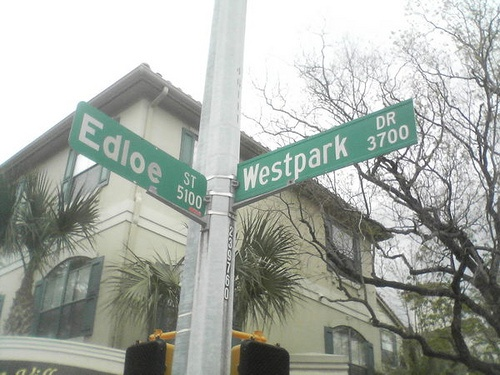Describe the objects in this image and their specific colors. I can see traffic light in white, black, olive, and gray tones and traffic light in white, black, gray, olive, and tan tones in this image. 